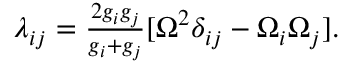Convert formula to latex. <formula><loc_0><loc_0><loc_500><loc_500>\begin{array} { r } { \lambda _ { i j } = \frac { 2 g _ { i } g _ { j } } { g _ { i } + g _ { j } } [ { \boldsymbol \Omega } ^ { 2 } \delta _ { i j } - \Omega _ { i } \Omega _ { j } ] . } \end{array}</formula> 